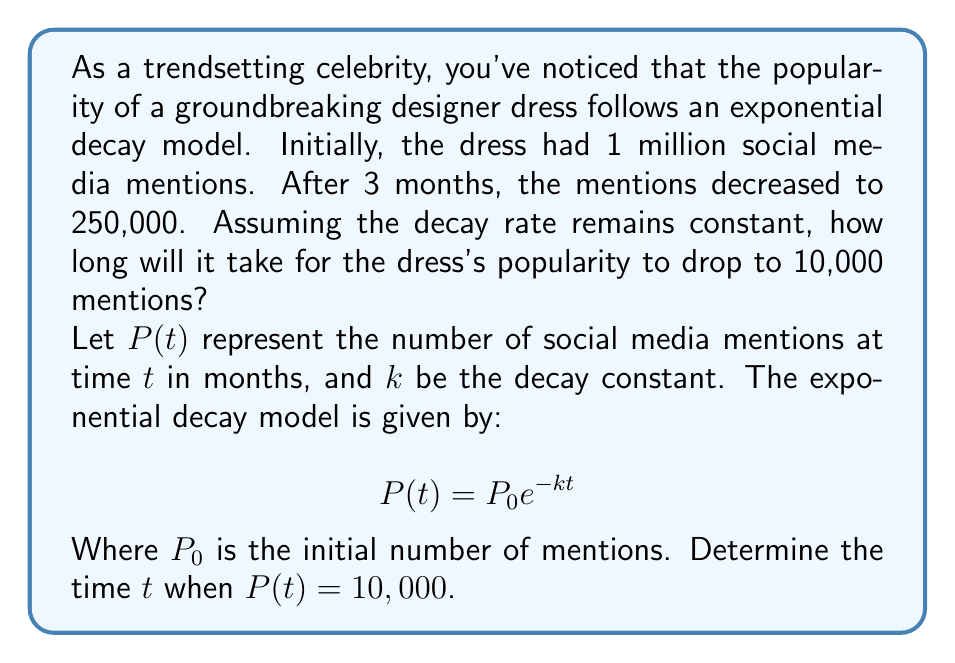Could you help me with this problem? Let's solve this problem step by step:

1) We know that $P_0 = 1,000,000$ (initial mentions) and after 3 months, $P(3) = 250,000$.

2) We can use these values to find the decay constant $k$:

   $$250,000 = 1,000,000e^{-3k}$$

3) Divide both sides by 1,000,000:

   $$0.25 = e^{-3k}$$

4) Take the natural logarithm of both sides:

   $$\ln(0.25) = -3k$$

5) Solve for $k$:

   $$k = -\frac{\ln(0.25)}{3} \approx 0.4621$$

6) Now that we have $k$, we can use the original equation to find $t$ when $P(t) = 10,000$:

   $$10,000 = 1,000,000e^{-0.4621t}$$

7) Divide both sides by 1,000,000:

   $$0.01 = e^{-0.4621t}$$

8) Take the natural logarithm of both sides:

   $$\ln(0.01) = -0.4621t$$

9) Solve for $t$:

   $$t = -\frac{\ln(0.01)}{0.4621} \approx 9.97$$

Therefore, it will take approximately 9.97 months for the dress's popularity to drop to 10,000 mentions.
Answer: It will take approximately 9.97 months for the dress's popularity to drop to 10,000 mentions. 